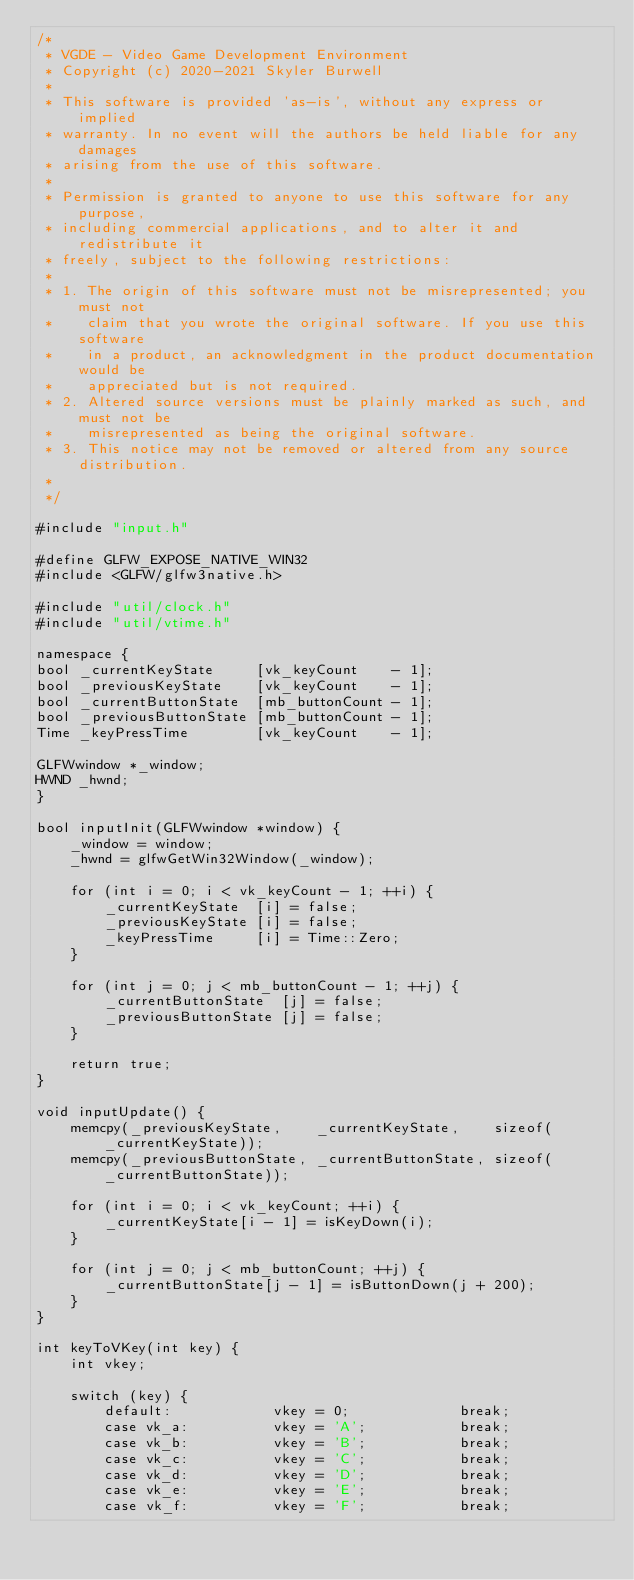<code> <loc_0><loc_0><loc_500><loc_500><_C++_>/*
 * VGDE - Video Game Development Environment
 * Copyright (c) 2020-2021 Skyler Burwell
 *
 * This software is provided 'as-is', without any express or implied
 * warranty. In no event will the authors be held liable for any damages
 * arising from the use of this software.
 *
 * Permission is granted to anyone to use this software for any purpose,
 * including commercial applications, and to alter it and redistribute it
 * freely, subject to the following restrictions:
 *
 * 1. The origin of this software must not be misrepresented; you must not
 *    claim that you wrote the original software. If you use this software
 *    in a product, an acknowledgment in the product documentation would be
 *    appreciated but is not required.
 * 2. Altered source versions must be plainly marked as such, and must not be
 *    misrepresented as being the original software.
 * 3. This notice may not be removed or altered from any source distribution.
 *
 */

#include "input.h"

#define GLFW_EXPOSE_NATIVE_WIN32
#include <GLFW/glfw3native.h>

#include "util/clock.h"
#include "util/vtime.h"

namespace {
bool _currentKeyState     [vk_keyCount    - 1];
bool _previousKeyState    [vk_keyCount    - 1];
bool _currentButtonState  [mb_buttonCount - 1];
bool _previousButtonState [mb_buttonCount - 1];
Time _keyPressTime        [vk_keyCount    - 1];

GLFWwindow *_window;
HWND _hwnd;
}

bool inputInit(GLFWwindow *window) {
	_window = window;
	_hwnd = glfwGetWin32Window(_window);

	for (int i = 0; i < vk_keyCount - 1; ++i) {
		_currentKeyState  [i] = false;
		_previousKeyState [i] = false;
		_keyPressTime     [i] = Time::Zero;
	}

	for (int j = 0; j < mb_buttonCount - 1; ++j) {
		_currentButtonState  [j] = false;
		_previousButtonState [j] = false;
	}

	return true;
}

void inputUpdate() {
	memcpy(_previousKeyState,    _currentKeyState,    sizeof(_currentKeyState));
	memcpy(_previousButtonState, _currentButtonState, sizeof(_currentButtonState));

	for (int i = 0; i < vk_keyCount; ++i) {
		_currentKeyState[i - 1] = isKeyDown(i);
	}

	for (int j = 0; j < mb_buttonCount; ++j) {
		_currentButtonState[j - 1] = isButtonDown(j + 200);
	}
}

int keyToVKey(int key) {
	int vkey;
	
	switch (key) {
		default:            vkey = 0;             break;
		case vk_a:          vkey = 'A';           break;
		case vk_b:          vkey = 'B';           break;
		case vk_c:          vkey = 'C';           break;
		case vk_d:          vkey = 'D';           break;
		case vk_e:          vkey = 'E';           break;
		case vk_f:          vkey = 'F';           break;</code> 